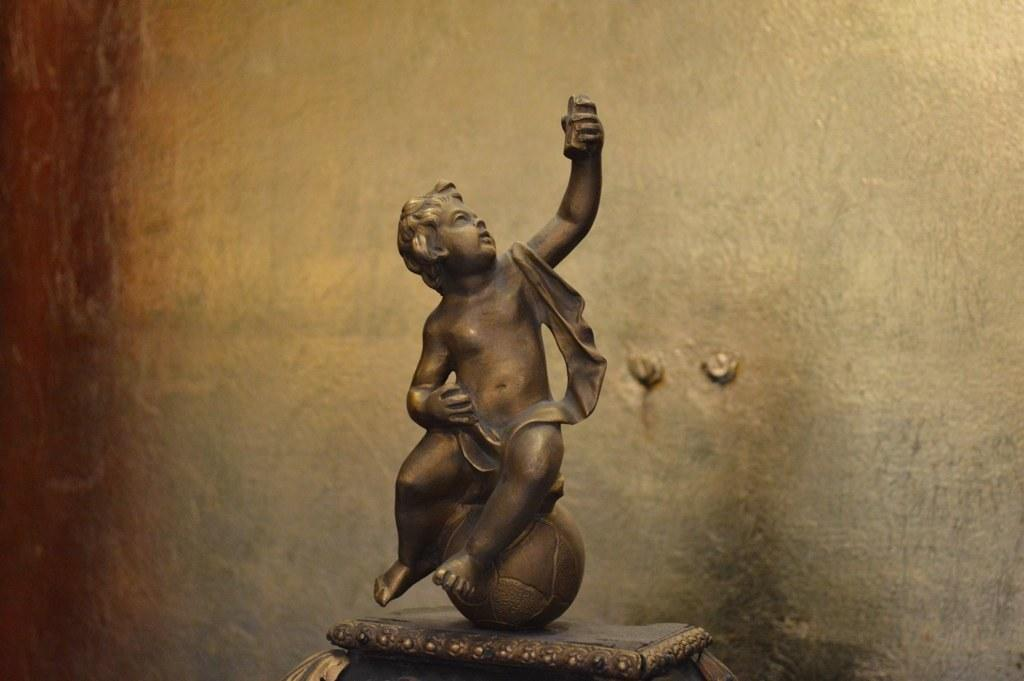What is the main subject of the image? There is a statue of a person in the image. What color is the statue? The statue is brown in color. What colors can be seen in the background of the image? The background of the image is cream and brown. How many chickens are sitting on the chair next to the statue in the image? There are no chickens or chairs present in the image; it only features a statue of a person and a background with cream and brown colors. 